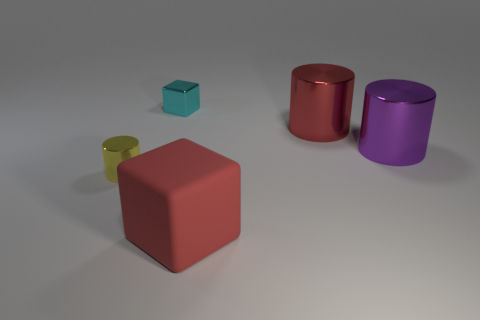What is the shape of the small object that is left of the tiny shiny object that is behind the small yellow shiny cylinder?
Give a very brief answer. Cylinder. There is a large purple shiny thing; is it the same shape as the large red object to the right of the big red block?
Give a very brief answer. Yes. What number of tiny cyan metal cubes are to the left of the shiny cylinder in front of the big purple metallic cylinder?
Your answer should be very brief. 0. There is a cyan object that is the same shape as the big red rubber thing; what is its material?
Make the answer very short. Metal. How many green things are large rubber cubes or large shiny objects?
Ensure brevity in your answer.  0. Is there any other thing of the same color as the rubber block?
Your response must be concise. Yes. There is a small thing behind the cylinder left of the red shiny cylinder; what is its color?
Ensure brevity in your answer.  Cyan. Is the number of big metallic objects on the right side of the cyan cube less than the number of metal things that are behind the tiny yellow cylinder?
Provide a succinct answer. Yes. What number of things are cylinders right of the large cube or tiny cyan cylinders?
Provide a short and direct response. 2. There is a metallic cylinder on the right side of the red shiny object; does it have the same size as the cyan cube?
Ensure brevity in your answer.  No. 